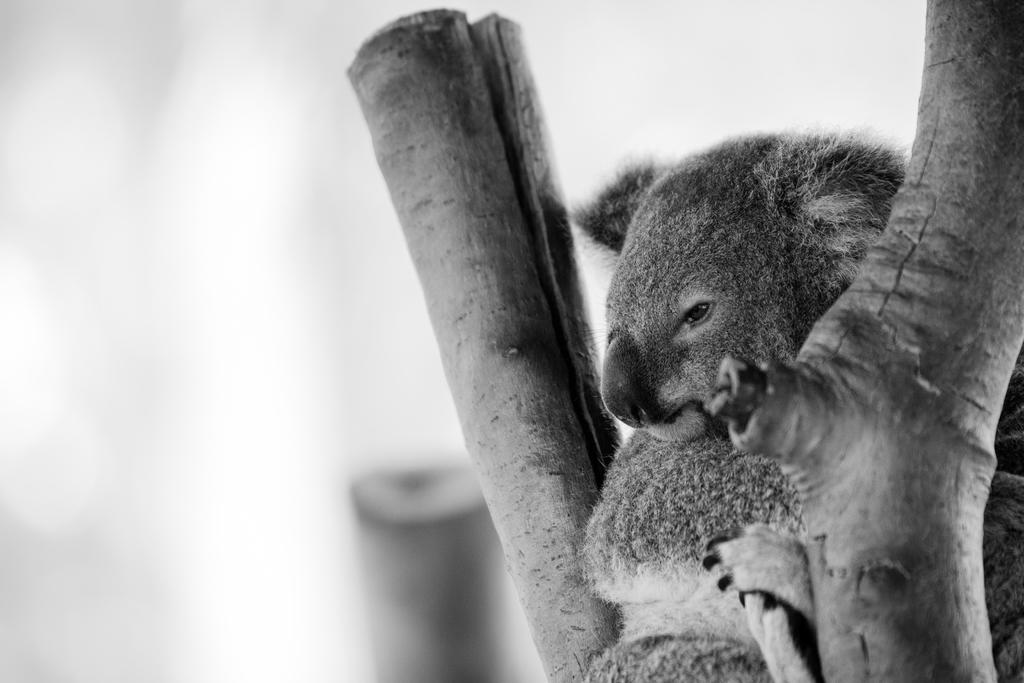What is the color scheme of the image? The image is black and white. What type of living creature can be seen in the image? There is an animal in the image. What natural elements are present in the image? Tree branches are visible in the image. How would you describe the background of the image? The background of the image is blurred. What type of apparel is the animal wearing in the image? There is no apparel visible on the animal in the image, as it is a black and white photograph. How many circles can be seen in the image? There are no circles present in the image; it features an animal and tree branches in a black and white setting. 